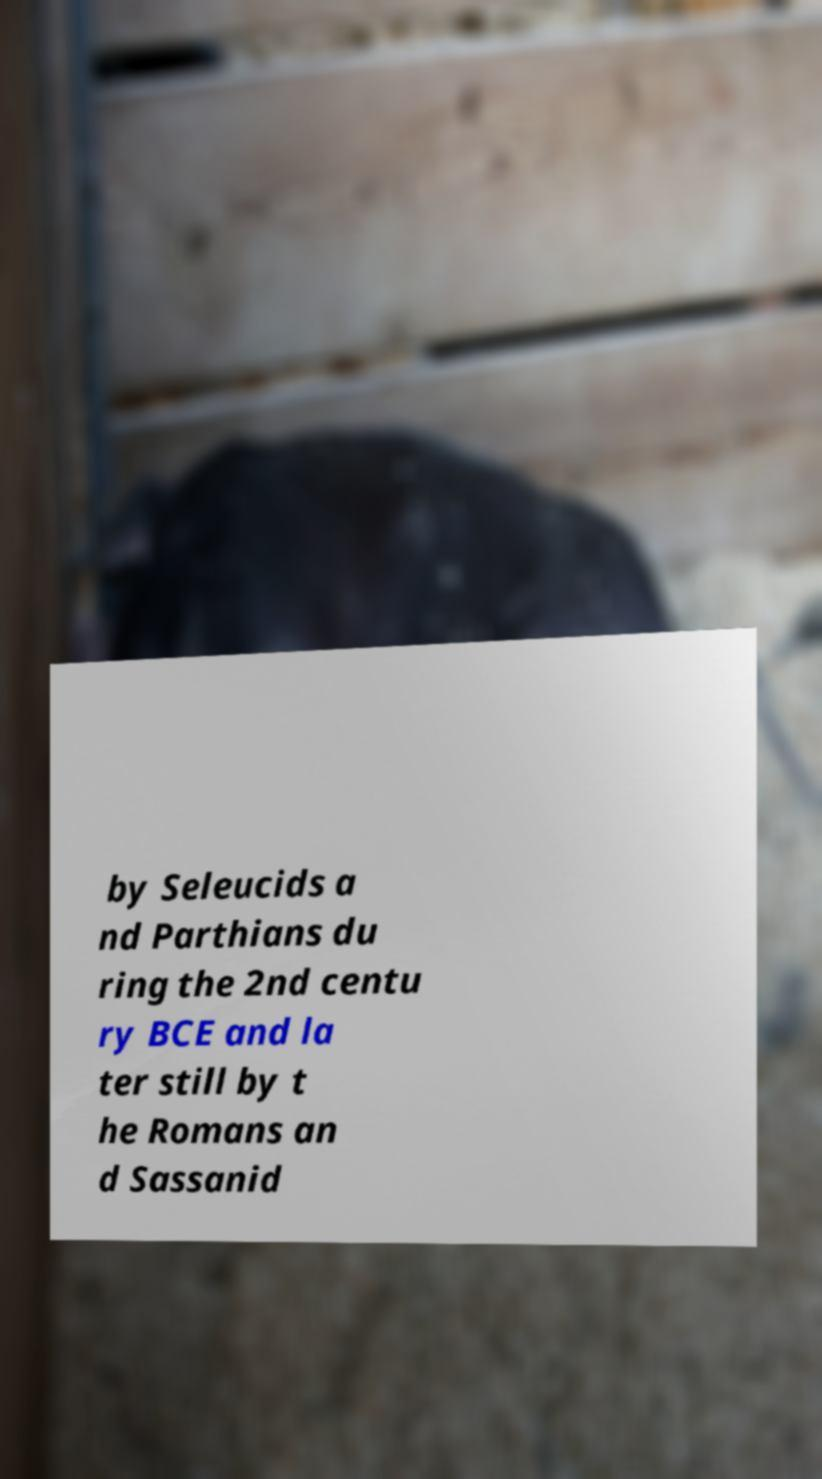For documentation purposes, I need the text within this image transcribed. Could you provide that? by Seleucids a nd Parthians du ring the 2nd centu ry BCE and la ter still by t he Romans an d Sassanid 